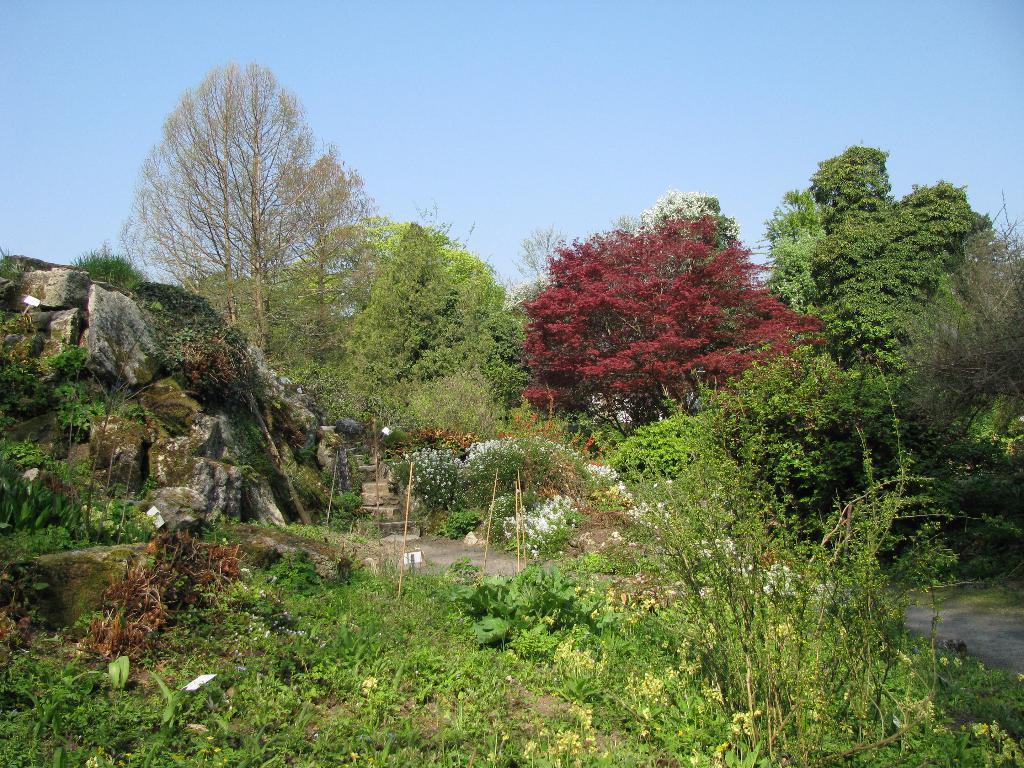In one or two sentences, can you explain what this image depicts? In this image there are many trees, plants. There is a rock, these are steps. The sky is clear. This is a path. 